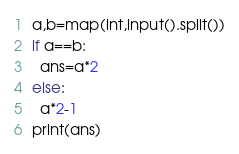Convert code to text. <code><loc_0><loc_0><loc_500><loc_500><_Python_>a,b=map(int,input().split())
if a==b:
  ans=a*2
else:
  a*2-1
print(ans)</code> 